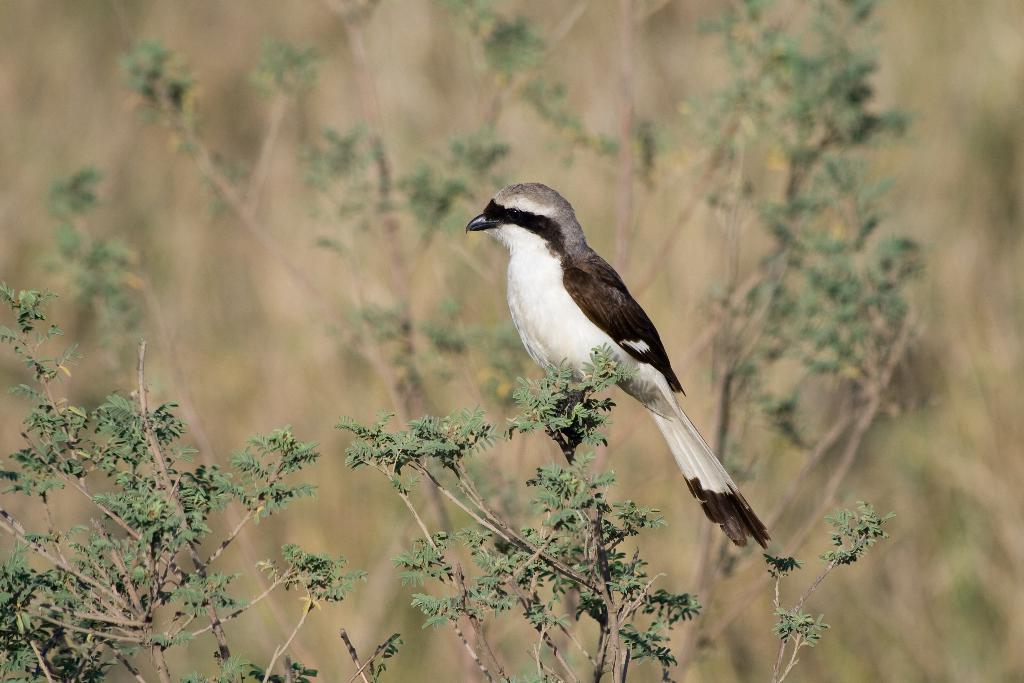Please provide a concise description of this image. In this image I can see a bird which is brown, black, ash and white in color is standing on a tree which is green and brown in color. In the background I can see few other trees which are blurry. 